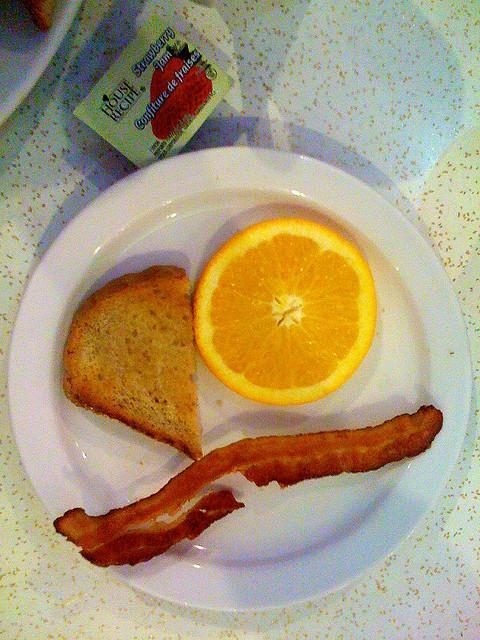How many red apples are there?
Give a very brief answer. 0. How many oranges are there?
Give a very brief answer. 1. How many slices of bread are here?
Give a very brief answer. 1. How many pears are on the plate?
Give a very brief answer. 0. How many oranges in the plate?
Give a very brief answer. 1. How many people are standing near the planes?
Give a very brief answer. 0. 